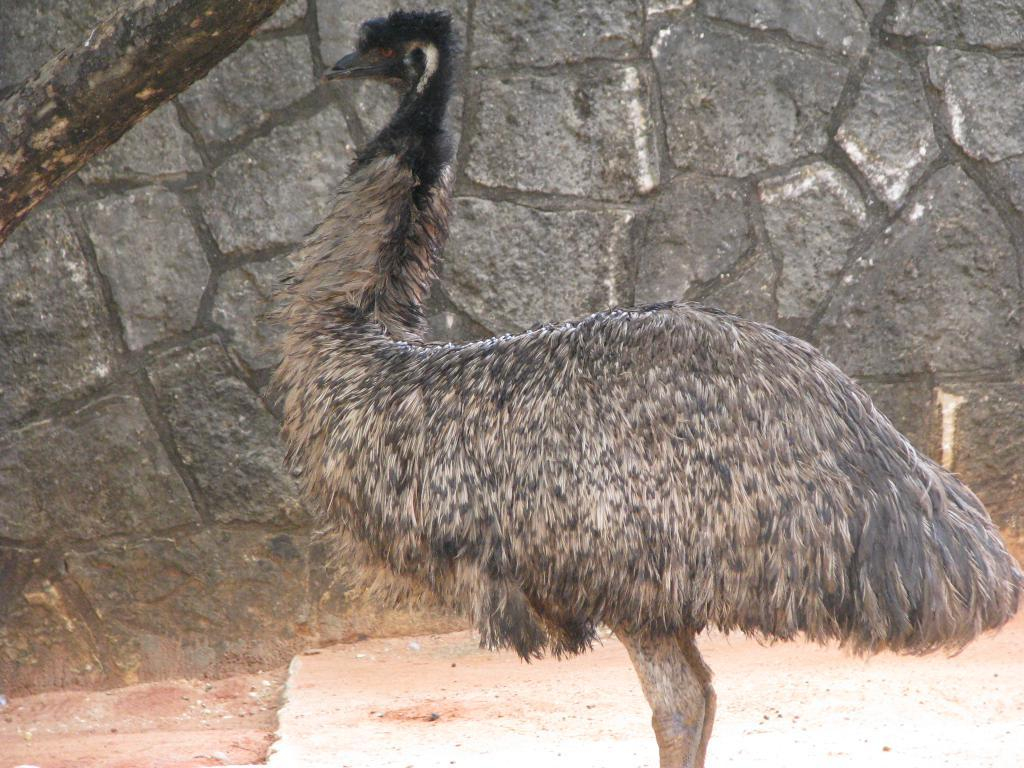What type of animal is in the picture? There is an emu in the picture. What is the texture or material shown in the picture? There is tree bark in the picture. What type of structure is visible in the picture? There is a wall in the picture. What type of grass is growing on the wall in the picture? There is no grass visible in the picture; it only shows an emu, tree bark, and a wall. 